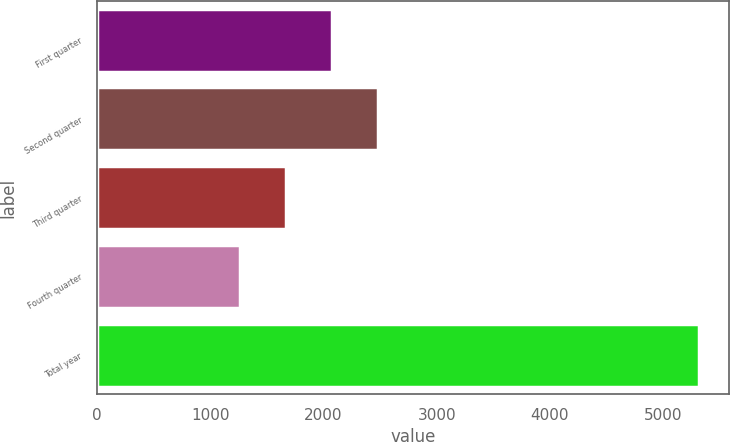Convert chart. <chart><loc_0><loc_0><loc_500><loc_500><bar_chart><fcel>First quarter<fcel>Second quarter<fcel>Third quarter<fcel>Fourth quarter<fcel>Total year<nl><fcel>2073.58<fcel>2479.27<fcel>1667.89<fcel>1262.2<fcel>5319.1<nl></chart> 